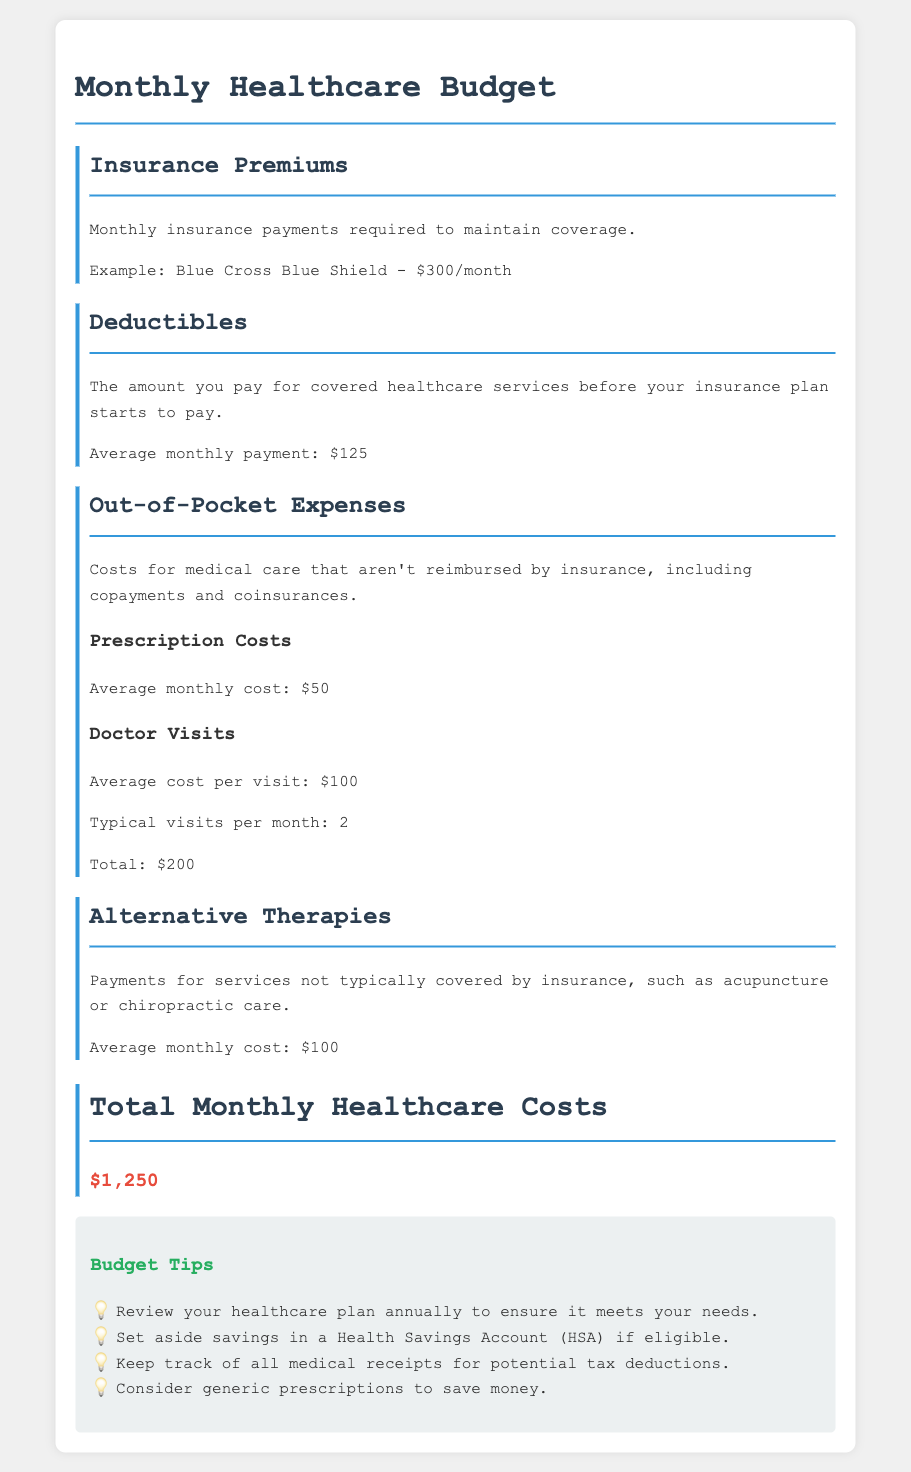What is the average monthly cost for prescription drugs? The document states that the average monthly cost for prescription drugs is $50.
Answer: $50 How much is the monthly insurance premium? The document provides an example premium for Blue Cross Blue Shield, which is $300 per month.
Answer: $300 What is the total for doctor visits per month? The document mentions that the average cost per visit is $100 and typical visits per month are 2, resulting in a total of $200 for doctor visits.
Answer: $200 What is the average monthly cost for alternative therapies? The document specifies the average monthly cost for alternative therapies, such as acupuncture or chiropractic care, is $100.
Answer: $100 What is the total monthly healthcare cost? The document sums up all expenses, stating that total monthly healthcare costs amount to $1,250.
Answer: $1,250 What is the average deductible per month? The document indicates that the average monthly deductible payment is $125.
Answer: $125 How many typical doctor visits are mentioned? The document specifies that there are typically 2 doctor visits mentioned per month.
Answer: 2 What should you set aside if eligible? The document suggests setting aside savings in a Health Savings Account (HSA) if eligible.
Answer: Health Savings Account (HSA) What is the purpose of keeping medical receipts? The document notes that keeping track of all medical receipts can lead to potential tax deductions.
Answer: Tax deductions 